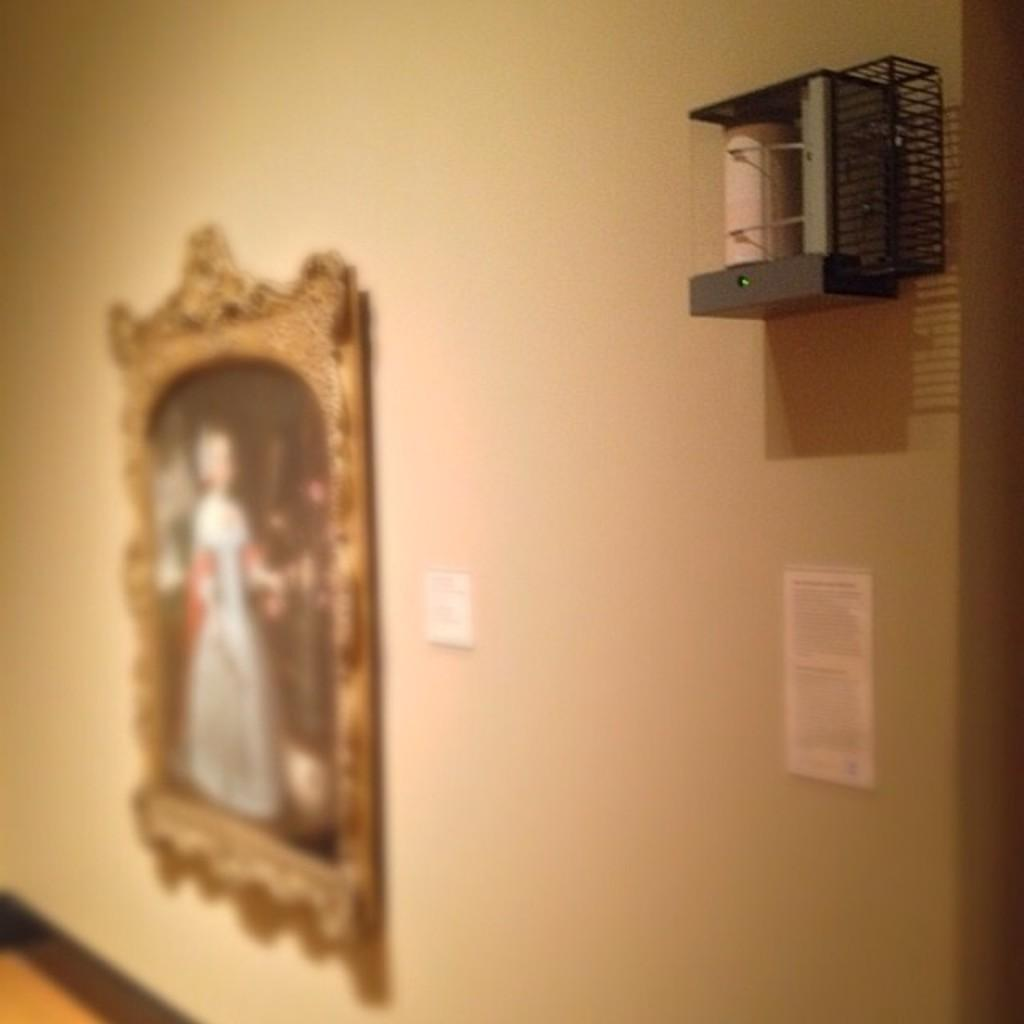What is the main subject of the image? The main subject of the image is a frame. What is inside the frame? There are papers in the image. What is attached to the wall in the image? There is an object attached to the wall in the image. What type of songs can be heard playing from the unit in the image? There is no unit or songs present in the image; it only features a frame with papers and an object attached to the wall. 